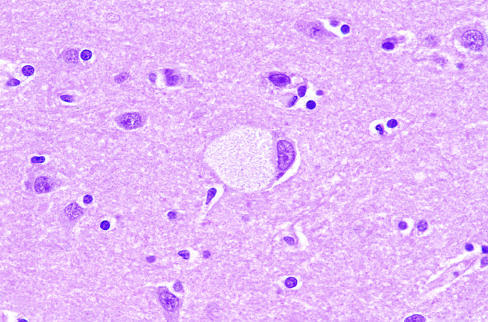does a large neuron have obvious lipid vacuolation under the light microscope?
Answer the question using a single word or phrase. Yes 